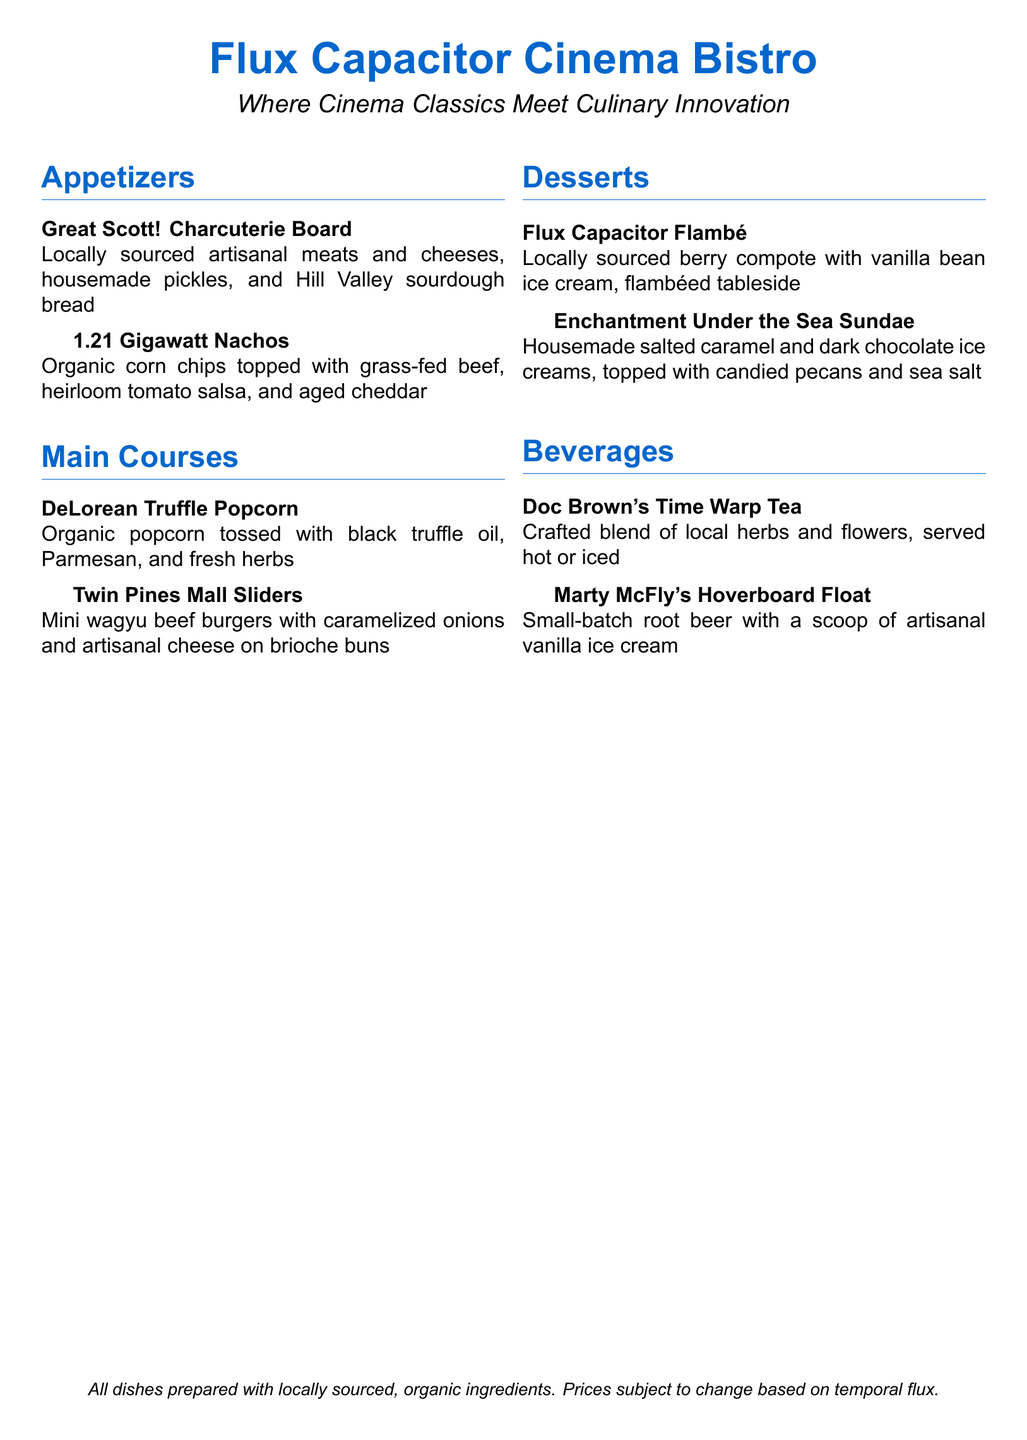What is the name of the first appetizer? The name of the first appetizer listed in the menu is the "Great Scott! Charcuterie Board."
Answer: Great Scott! Charcuterie Board How many main courses are listed on the menu? The menu lists two main courses: DeLorean Truffle Popcorn and Twin Pines Mall Sliders.
Answer: 2 What ingredient is used in the Flux Capacitor Flambé? The Flux Capacitor Flambé features locally sourced berry compote with vanilla bean ice cream.
Answer: berry compote What type of tea is offered in the beverages section? Doc Brown's Time Warp Tea is the type of tea available on the menu.
Answer: Doc Brown's Time Warp Tea What is the main protein in the 1.21 Gigawatt Nachos? The main protein in the 1.21 Gigawatt Nachos is grass-fed beef.
Answer: grass-fed beef Which dessert includes dark chocolate ice cream? The dessert that includes dark chocolate ice cream is the Enchantment Under the Sea Sundae.
Answer: Enchantment Under the Sea Sundae What type of bread is served with the charcuterie board? The charcuterie board is served with Hill Valley sourdough bread.
Answer: Hill Valley sourdough bread What is the special preparation method for the Flux Capacitor Flambé? The special preparation method for the Flux Capacitor Flambé is that it is flambéed tableside.
Answer: flambéed tableside How is the Hoverboard Float topped? The Hoverboard Float is topped with a scoop of artisanal vanilla ice cream.
Answer: artisanal vanilla ice cream 